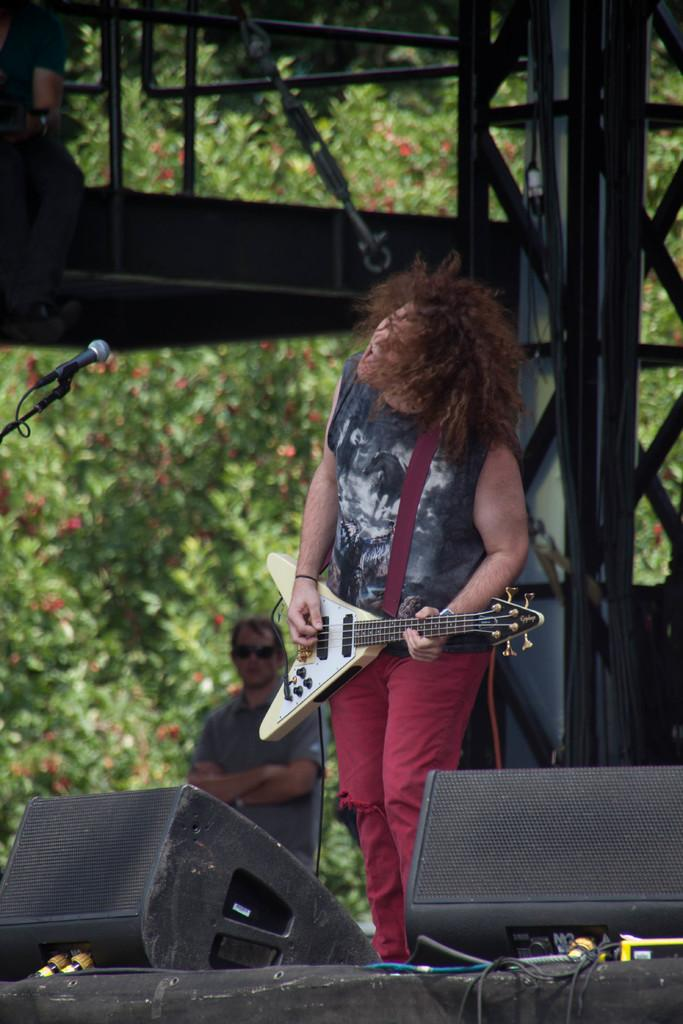What is the man in the image doing? The man is playing the guitar and singing into a microphone. What instrument is the man holding in the image? The man is holding a guitar in the image. Can you describe the background of the image? There are trees and a pillar in the background of the image. Is there anyone else in the image besides the man? Yes, there is a person in the background looking at the man. What time of day is it in the image, and what substance is the man using to enhance his performance? The time of day is not mentioned in the image, and there is no indication of any substance being used to enhance the man's performance. 